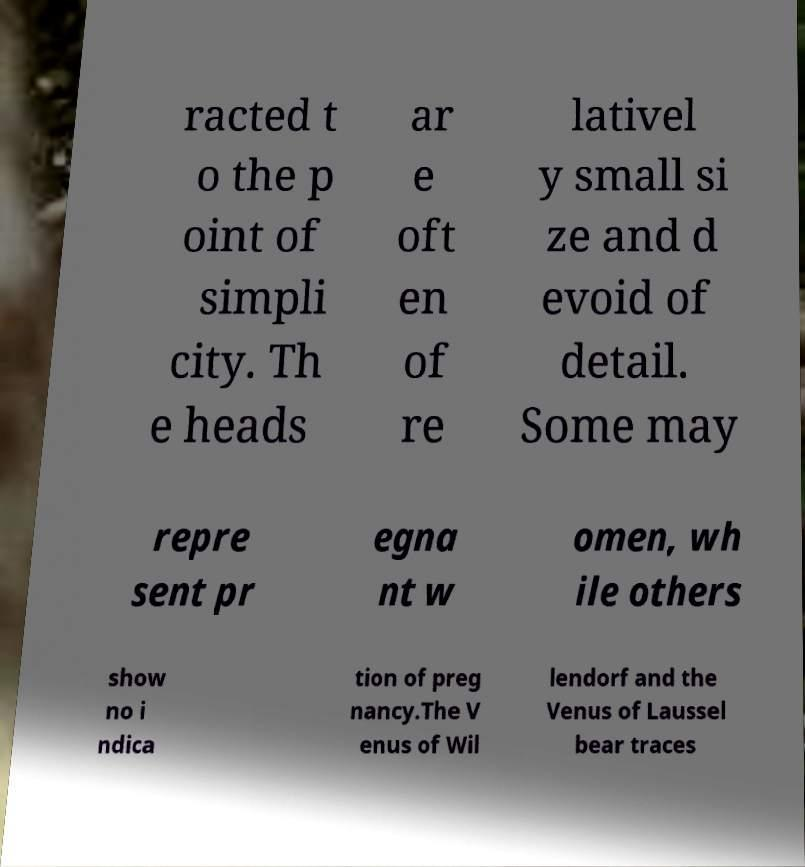Can you accurately transcribe the text from the provided image for me? racted t o the p oint of simpli city. Th e heads ar e oft en of re lativel y small si ze and d evoid of detail. Some may repre sent pr egna nt w omen, wh ile others show no i ndica tion of preg nancy.The V enus of Wil lendorf and the Venus of Laussel bear traces 